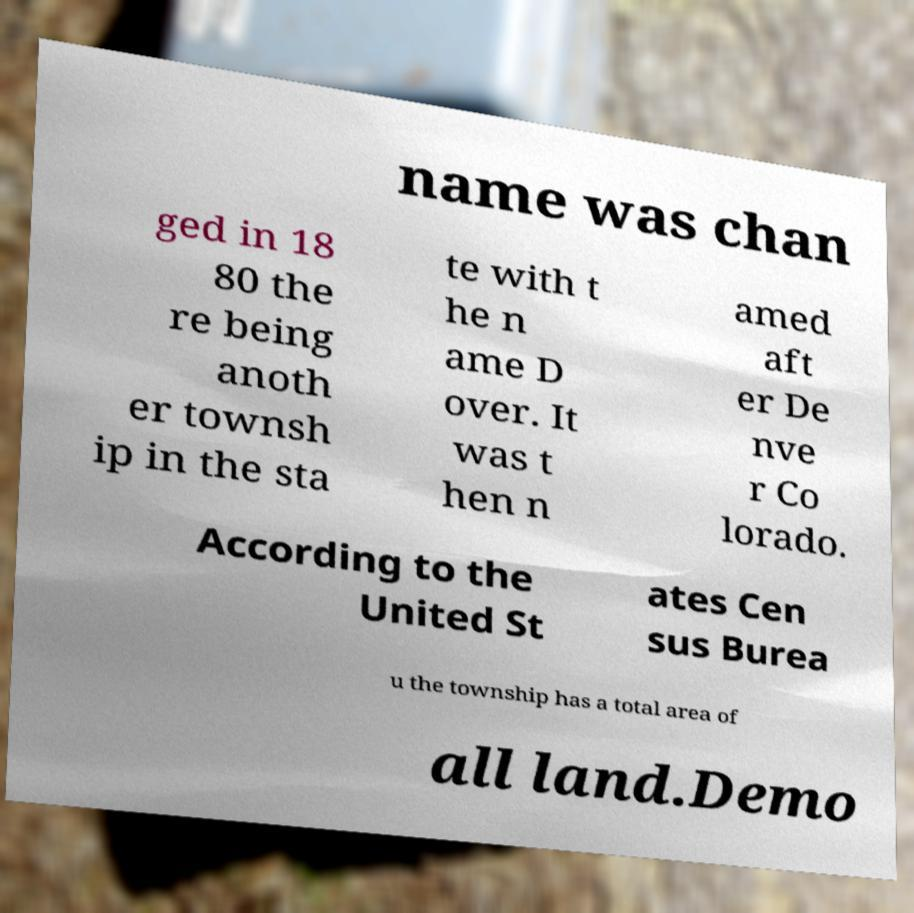There's text embedded in this image that I need extracted. Can you transcribe it verbatim? name was chan ged in 18 80 the re being anoth er townsh ip in the sta te with t he n ame D over. It was t hen n amed aft er De nve r Co lorado. According to the United St ates Cen sus Burea u the township has a total area of all land.Demo 